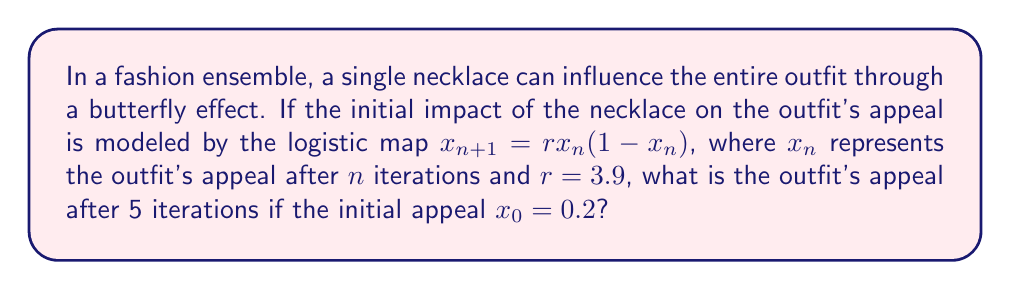Solve this math problem. To solve this problem, we need to iterate the logistic map equation five times, starting with $x_0 = 0.2$ and $r = 3.9$. Let's calculate step by step:

1) For $n = 0$:
   $x_1 = 3.9 \cdot 0.2 \cdot (1-0.2) = 3.9 \cdot 0.2 \cdot 0.8 = 0.624$

2) For $n = 1$:
   $x_2 = 3.9 \cdot 0.624 \cdot (1-0.624) = 3.9 \cdot 0.624 \cdot 0.376 = 0.916896$

3) For $n = 2$:
   $x_3 = 3.9 \cdot 0.916896 \cdot (1-0.916896) = 3.9 \cdot 0.916896 \cdot 0.083104 = 0.297499$

4) For $n = 3$:
   $x_4 = 3.9 \cdot 0.297499 \cdot (1-0.297499) = 3.9 \cdot 0.297499 \cdot 0.702501 = 0.816224$

5) For $n = 4$:
   $x_5 = 3.9 \cdot 0.816224 \cdot (1-0.816224) = 3.9 \cdot 0.816224 \cdot 0.183776 = 0.585506$

Therefore, after 5 iterations, the outfit's appeal is approximately 0.585506.
Answer: 0.585506 